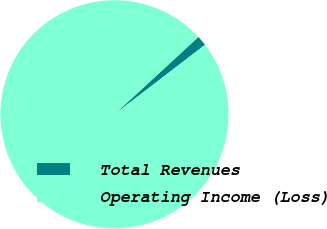Convert chart to OTSL. <chart><loc_0><loc_0><loc_500><loc_500><pie_chart><fcel>Total Revenues<fcel>Operating Income (Loss)<nl><fcel>1.43%<fcel>98.57%<nl></chart> 